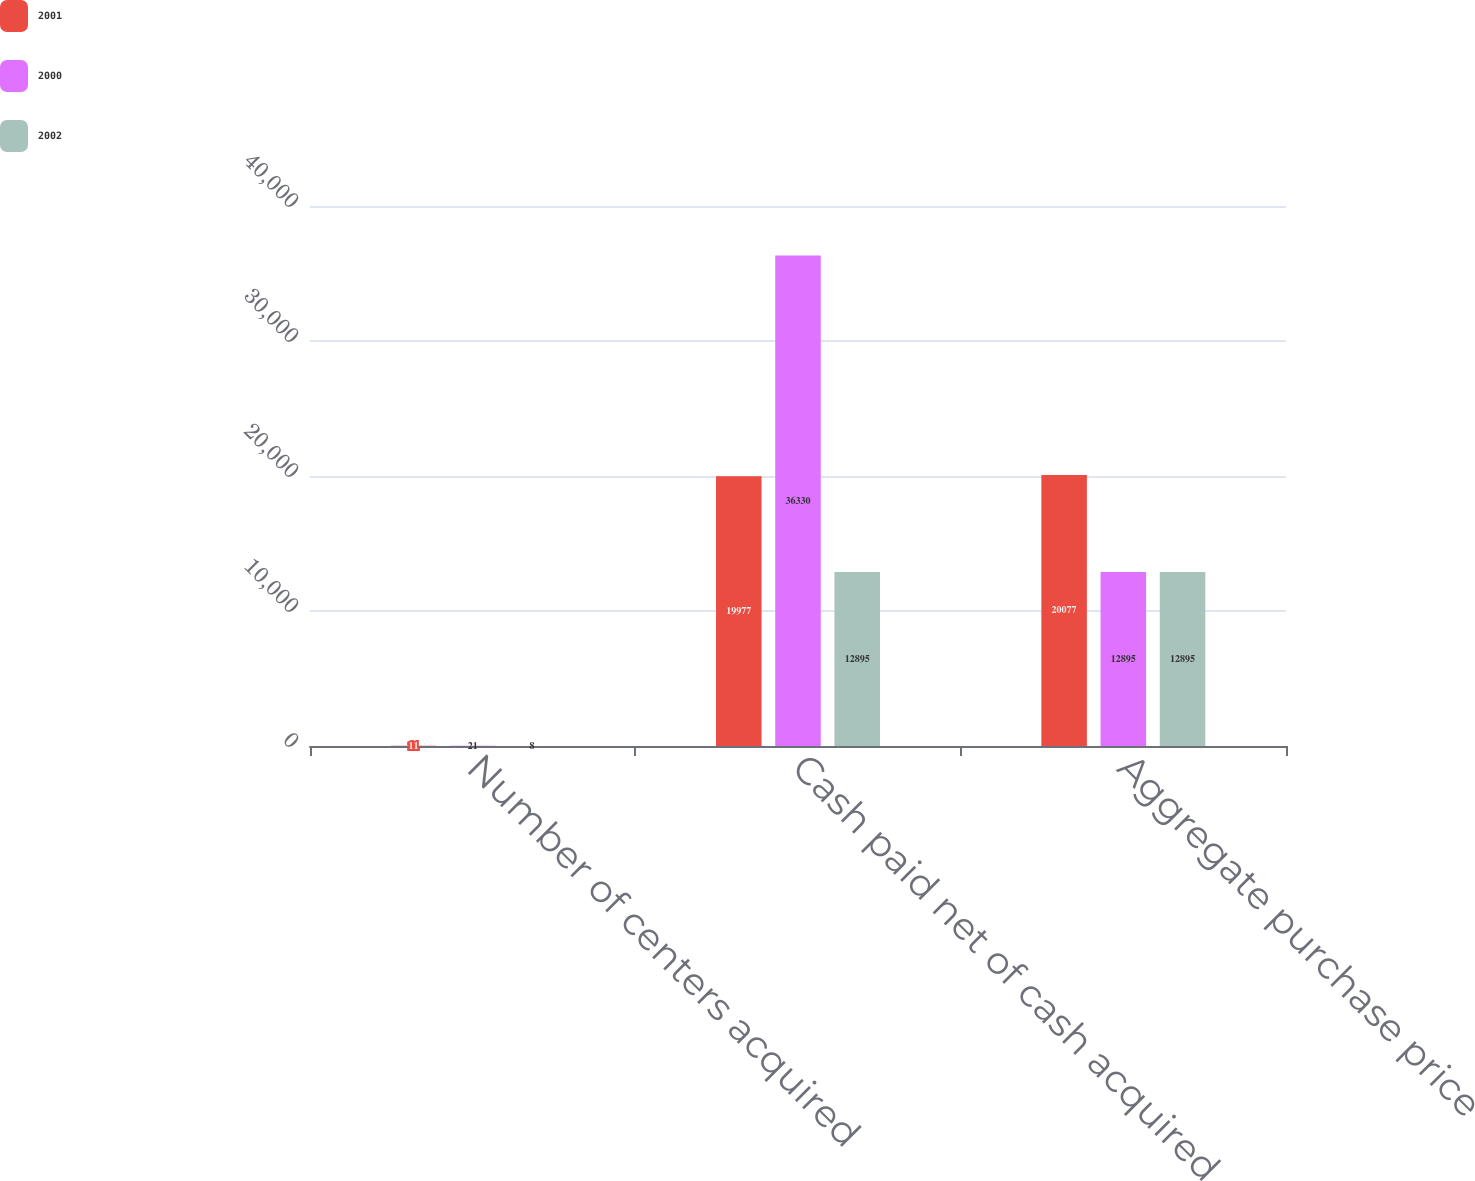Convert chart. <chart><loc_0><loc_0><loc_500><loc_500><stacked_bar_chart><ecel><fcel>Number of centers acquired<fcel>Cash paid net of cash acquired<fcel>Aggregate purchase price<nl><fcel>2001<fcel>11<fcel>19977<fcel>20077<nl><fcel>2000<fcel>21<fcel>36330<fcel>12895<nl><fcel>2002<fcel>8<fcel>12895<fcel>12895<nl></chart> 